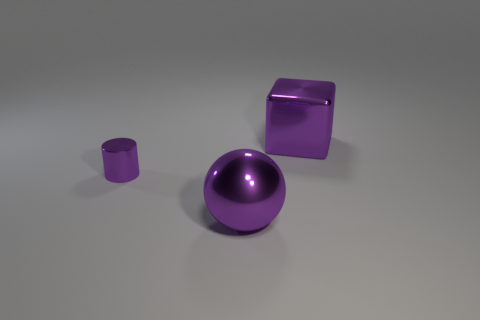The purple metal thing that is behind the purple cylinder has what shape?
Provide a short and direct response. Cube. How many purple metal objects are on the right side of the tiny purple shiny cylinder and in front of the purple block?
Give a very brief answer. 1. Do the cube and the object in front of the small metal object have the same size?
Your answer should be compact. Yes. There is a ball that is in front of the big shiny thing that is to the right of the large purple shiny thing on the left side of the big purple shiny block; what is its size?
Your response must be concise. Large. There is a purple object on the left side of the purple metallic sphere; what is its size?
Your answer should be very brief. Small. There is a large thing that is the same material as the purple sphere; what is its shape?
Ensure brevity in your answer.  Cube. Are the thing that is in front of the purple metallic cylinder and the small cylinder made of the same material?
Your answer should be compact. Yes. How many other objects are the same material as the purple ball?
Keep it short and to the point. 2. What number of things are large purple objects behind the sphere or big shiny things right of the large metal ball?
Ensure brevity in your answer.  1. There is a large metallic thing left of the big purple metal block; does it have the same shape as the purple metal thing on the right side of the big purple shiny ball?
Provide a succinct answer. No. 